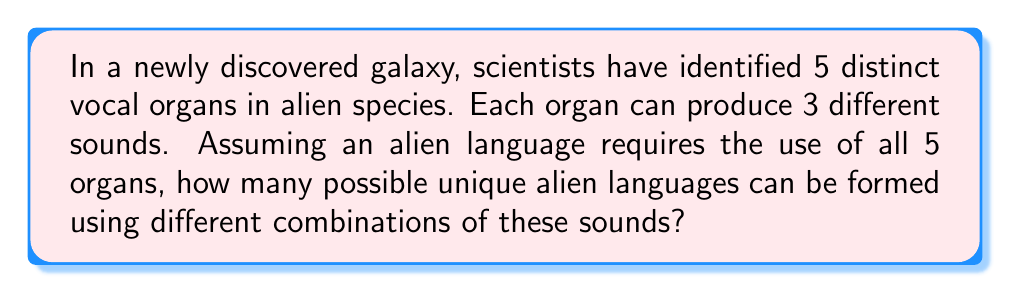Help me with this question. Let's approach this step-by-step:

1) Each vocal organ can produce 3 different sounds. This means for each organ, there are 3 choices.

2) The language requires the use of all 5 organs. This means we need to make a choice for each of the 5 organs.

3) When we have a series of independent choices, we multiply the number of possibilities for each choice. This is the Multiplication Principle.

4) In this case, we have 5 independent choices (one for each organ), and each choice has 3 possibilities.

5) Therefore, the total number of possible combinations is:

   $$3 \times 3 \times 3 \times 3 \times 3 = 3^5$$

6) We can calculate this:

   $$3^5 = 3 \times 3 \times 3 \times 3 \times 3 = 243$$

Thus, there are 243 possible unique alien languages that can be formed.

This problem demonstrates how exponents can be used to calculate combinations, a concept often explored in science fiction world-building.
Answer: $3^5 = 243$ 